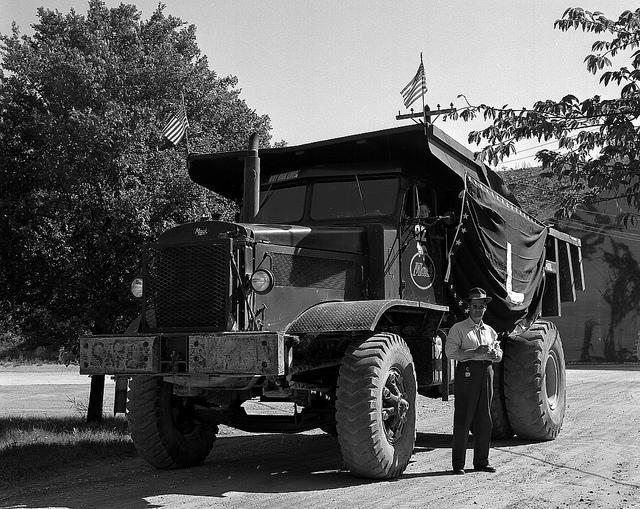Does the image validate the caption "The truck is at the left side of the person."?
Answer yes or no. Yes. 